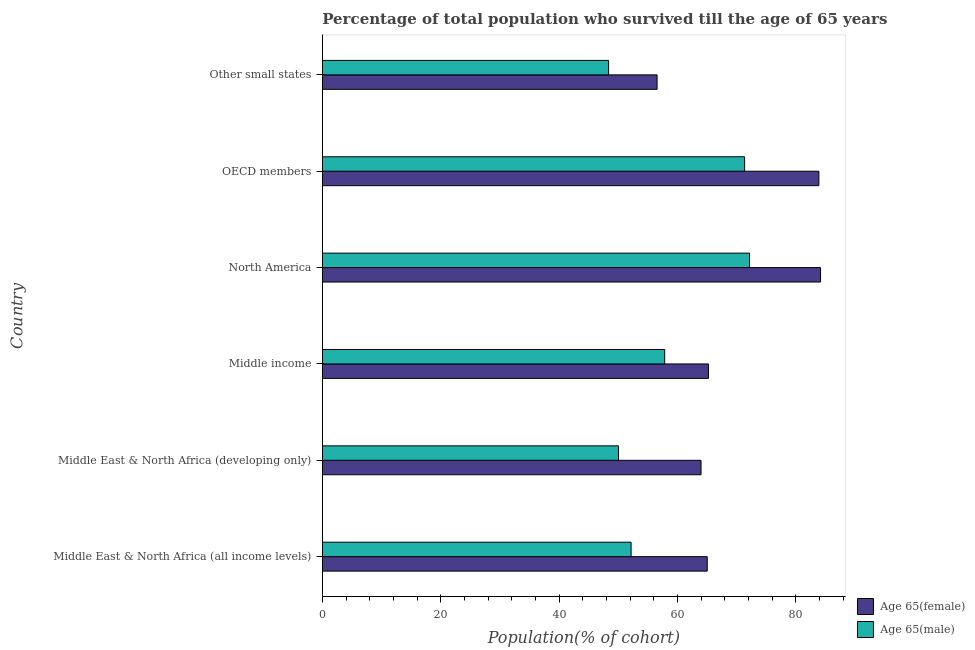How many different coloured bars are there?
Provide a succinct answer. 2. How many groups of bars are there?
Your answer should be very brief. 6. How many bars are there on the 1st tick from the bottom?
Provide a short and direct response. 2. What is the label of the 1st group of bars from the top?
Your answer should be very brief. Other small states. In how many cases, is the number of bars for a given country not equal to the number of legend labels?
Provide a succinct answer. 0. What is the percentage of female population who survived till age of 65 in Middle East & North Africa (all income levels)?
Ensure brevity in your answer.  65.04. Across all countries, what is the maximum percentage of male population who survived till age of 65?
Offer a very short reply. 72.19. Across all countries, what is the minimum percentage of male population who survived till age of 65?
Offer a terse response. 48.37. In which country was the percentage of male population who survived till age of 65 maximum?
Offer a terse response. North America. In which country was the percentage of female population who survived till age of 65 minimum?
Give a very brief answer. Other small states. What is the total percentage of male population who survived till age of 65 in the graph?
Ensure brevity in your answer.  351.99. What is the difference between the percentage of female population who survived till age of 65 in OECD members and that in Other small states?
Your response must be concise. 27.34. What is the difference between the percentage of female population who survived till age of 65 in Middle income and the percentage of male population who survived till age of 65 in Middle East & North Africa (developing only)?
Your response must be concise. 15.2. What is the average percentage of male population who survived till age of 65 per country?
Give a very brief answer. 58.67. What is the difference between the percentage of male population who survived till age of 65 and percentage of female population who survived till age of 65 in North America?
Offer a terse response. -12. What is the ratio of the percentage of male population who survived till age of 65 in OECD members to that in Other small states?
Provide a succinct answer. 1.48. Is the percentage of male population who survived till age of 65 in North America less than that in OECD members?
Keep it short and to the point. No. What is the difference between the highest and the second highest percentage of male population who survived till age of 65?
Offer a very short reply. 0.83. What is the difference between the highest and the lowest percentage of female population who survived till age of 65?
Your answer should be very brief. 27.62. Is the sum of the percentage of female population who survived till age of 65 in Middle East & North Africa (developing only) and Middle income greater than the maximum percentage of male population who survived till age of 65 across all countries?
Your answer should be very brief. Yes. What does the 1st bar from the top in Other small states represents?
Provide a succinct answer. Age 65(male). What does the 2nd bar from the bottom in OECD members represents?
Provide a succinct answer. Age 65(male). How many countries are there in the graph?
Offer a terse response. 6. Does the graph contain any zero values?
Ensure brevity in your answer.  No. Does the graph contain grids?
Provide a short and direct response. No. Where does the legend appear in the graph?
Give a very brief answer. Bottom right. What is the title of the graph?
Offer a terse response. Percentage of total population who survived till the age of 65 years. What is the label or title of the X-axis?
Your answer should be very brief. Population(% of cohort). What is the Population(% of cohort) of Age 65(female) in Middle East & North Africa (all income levels)?
Your answer should be very brief. 65.04. What is the Population(% of cohort) of Age 65(male) in Middle East & North Africa (all income levels)?
Keep it short and to the point. 52.18. What is the Population(% of cohort) in Age 65(female) in Middle East & North Africa (developing only)?
Provide a short and direct response. 63.99. What is the Population(% of cohort) of Age 65(male) in Middle East & North Africa (developing only)?
Your answer should be compact. 50.05. What is the Population(% of cohort) in Age 65(female) in Middle income?
Your answer should be compact. 65.25. What is the Population(% of cohort) of Age 65(male) in Middle income?
Your response must be concise. 57.85. What is the Population(% of cohort) of Age 65(female) in North America?
Offer a very short reply. 84.19. What is the Population(% of cohort) in Age 65(male) in North America?
Your response must be concise. 72.19. What is the Population(% of cohort) of Age 65(female) in OECD members?
Provide a succinct answer. 83.91. What is the Population(% of cohort) of Age 65(male) in OECD members?
Offer a very short reply. 71.36. What is the Population(% of cohort) of Age 65(female) in Other small states?
Keep it short and to the point. 56.57. What is the Population(% of cohort) in Age 65(male) in Other small states?
Ensure brevity in your answer.  48.37. Across all countries, what is the maximum Population(% of cohort) in Age 65(female)?
Provide a succinct answer. 84.19. Across all countries, what is the maximum Population(% of cohort) in Age 65(male)?
Offer a very short reply. 72.19. Across all countries, what is the minimum Population(% of cohort) of Age 65(female)?
Offer a terse response. 56.57. Across all countries, what is the minimum Population(% of cohort) in Age 65(male)?
Ensure brevity in your answer.  48.37. What is the total Population(% of cohort) in Age 65(female) in the graph?
Provide a succinct answer. 418.96. What is the total Population(% of cohort) of Age 65(male) in the graph?
Your response must be concise. 351.99. What is the difference between the Population(% of cohort) of Age 65(female) in Middle East & North Africa (all income levels) and that in Middle East & North Africa (developing only)?
Offer a very short reply. 1.05. What is the difference between the Population(% of cohort) of Age 65(male) in Middle East & North Africa (all income levels) and that in Middle East & North Africa (developing only)?
Your answer should be compact. 2.13. What is the difference between the Population(% of cohort) in Age 65(female) in Middle East & North Africa (all income levels) and that in Middle income?
Offer a terse response. -0.21. What is the difference between the Population(% of cohort) in Age 65(male) in Middle East & North Africa (all income levels) and that in Middle income?
Provide a short and direct response. -5.67. What is the difference between the Population(% of cohort) of Age 65(female) in Middle East & North Africa (all income levels) and that in North America?
Your response must be concise. -19.15. What is the difference between the Population(% of cohort) of Age 65(male) in Middle East & North Africa (all income levels) and that in North America?
Offer a very short reply. -20.01. What is the difference between the Population(% of cohort) in Age 65(female) in Middle East & North Africa (all income levels) and that in OECD members?
Keep it short and to the point. -18.86. What is the difference between the Population(% of cohort) in Age 65(male) in Middle East & North Africa (all income levels) and that in OECD members?
Your answer should be very brief. -19.18. What is the difference between the Population(% of cohort) of Age 65(female) in Middle East & North Africa (all income levels) and that in Other small states?
Your answer should be compact. 8.48. What is the difference between the Population(% of cohort) of Age 65(male) in Middle East & North Africa (all income levels) and that in Other small states?
Give a very brief answer. 3.8. What is the difference between the Population(% of cohort) of Age 65(female) in Middle East & North Africa (developing only) and that in Middle income?
Offer a terse response. -1.26. What is the difference between the Population(% of cohort) of Age 65(male) in Middle East & North Africa (developing only) and that in Middle income?
Provide a short and direct response. -7.8. What is the difference between the Population(% of cohort) of Age 65(female) in Middle East & North Africa (developing only) and that in North America?
Your response must be concise. -20.2. What is the difference between the Population(% of cohort) in Age 65(male) in Middle East & North Africa (developing only) and that in North America?
Offer a very short reply. -22.14. What is the difference between the Population(% of cohort) in Age 65(female) in Middle East & North Africa (developing only) and that in OECD members?
Give a very brief answer. -19.91. What is the difference between the Population(% of cohort) of Age 65(male) in Middle East & North Africa (developing only) and that in OECD members?
Provide a short and direct response. -21.31. What is the difference between the Population(% of cohort) of Age 65(female) in Middle East & North Africa (developing only) and that in Other small states?
Your response must be concise. 7.43. What is the difference between the Population(% of cohort) of Age 65(male) in Middle East & North Africa (developing only) and that in Other small states?
Offer a terse response. 1.68. What is the difference between the Population(% of cohort) of Age 65(female) in Middle income and that in North America?
Your response must be concise. -18.94. What is the difference between the Population(% of cohort) of Age 65(male) in Middle income and that in North America?
Give a very brief answer. -14.34. What is the difference between the Population(% of cohort) in Age 65(female) in Middle income and that in OECD members?
Your response must be concise. -18.66. What is the difference between the Population(% of cohort) in Age 65(male) in Middle income and that in OECD members?
Give a very brief answer. -13.51. What is the difference between the Population(% of cohort) of Age 65(female) in Middle income and that in Other small states?
Offer a very short reply. 8.68. What is the difference between the Population(% of cohort) in Age 65(male) in Middle income and that in Other small states?
Offer a very short reply. 9.48. What is the difference between the Population(% of cohort) of Age 65(female) in North America and that in OECD members?
Provide a short and direct response. 0.28. What is the difference between the Population(% of cohort) of Age 65(male) in North America and that in OECD members?
Keep it short and to the point. 0.83. What is the difference between the Population(% of cohort) in Age 65(female) in North America and that in Other small states?
Give a very brief answer. 27.62. What is the difference between the Population(% of cohort) of Age 65(male) in North America and that in Other small states?
Ensure brevity in your answer.  23.81. What is the difference between the Population(% of cohort) in Age 65(female) in OECD members and that in Other small states?
Provide a succinct answer. 27.34. What is the difference between the Population(% of cohort) in Age 65(male) in OECD members and that in Other small states?
Make the answer very short. 22.98. What is the difference between the Population(% of cohort) in Age 65(female) in Middle East & North Africa (all income levels) and the Population(% of cohort) in Age 65(male) in Middle East & North Africa (developing only)?
Provide a short and direct response. 15. What is the difference between the Population(% of cohort) of Age 65(female) in Middle East & North Africa (all income levels) and the Population(% of cohort) of Age 65(male) in Middle income?
Your response must be concise. 7.19. What is the difference between the Population(% of cohort) in Age 65(female) in Middle East & North Africa (all income levels) and the Population(% of cohort) in Age 65(male) in North America?
Make the answer very short. -7.14. What is the difference between the Population(% of cohort) in Age 65(female) in Middle East & North Africa (all income levels) and the Population(% of cohort) in Age 65(male) in OECD members?
Keep it short and to the point. -6.31. What is the difference between the Population(% of cohort) of Age 65(female) in Middle East & North Africa (all income levels) and the Population(% of cohort) of Age 65(male) in Other small states?
Provide a succinct answer. 16.67. What is the difference between the Population(% of cohort) in Age 65(female) in Middle East & North Africa (developing only) and the Population(% of cohort) in Age 65(male) in Middle income?
Your answer should be compact. 6.14. What is the difference between the Population(% of cohort) in Age 65(female) in Middle East & North Africa (developing only) and the Population(% of cohort) in Age 65(male) in North America?
Make the answer very short. -8.19. What is the difference between the Population(% of cohort) of Age 65(female) in Middle East & North Africa (developing only) and the Population(% of cohort) of Age 65(male) in OECD members?
Your response must be concise. -7.36. What is the difference between the Population(% of cohort) in Age 65(female) in Middle East & North Africa (developing only) and the Population(% of cohort) in Age 65(male) in Other small states?
Give a very brief answer. 15.62. What is the difference between the Population(% of cohort) of Age 65(female) in Middle income and the Population(% of cohort) of Age 65(male) in North America?
Keep it short and to the point. -6.93. What is the difference between the Population(% of cohort) of Age 65(female) in Middle income and the Population(% of cohort) of Age 65(male) in OECD members?
Keep it short and to the point. -6.1. What is the difference between the Population(% of cohort) in Age 65(female) in Middle income and the Population(% of cohort) in Age 65(male) in Other small states?
Your answer should be compact. 16.88. What is the difference between the Population(% of cohort) in Age 65(female) in North America and the Population(% of cohort) in Age 65(male) in OECD members?
Give a very brief answer. 12.83. What is the difference between the Population(% of cohort) of Age 65(female) in North America and the Population(% of cohort) of Age 65(male) in Other small states?
Your answer should be very brief. 35.82. What is the difference between the Population(% of cohort) of Age 65(female) in OECD members and the Population(% of cohort) of Age 65(male) in Other small states?
Ensure brevity in your answer.  35.54. What is the average Population(% of cohort) in Age 65(female) per country?
Provide a succinct answer. 69.83. What is the average Population(% of cohort) of Age 65(male) per country?
Offer a very short reply. 58.67. What is the difference between the Population(% of cohort) in Age 65(female) and Population(% of cohort) in Age 65(male) in Middle East & North Africa (all income levels)?
Provide a succinct answer. 12.87. What is the difference between the Population(% of cohort) in Age 65(female) and Population(% of cohort) in Age 65(male) in Middle East & North Africa (developing only)?
Offer a terse response. 13.95. What is the difference between the Population(% of cohort) of Age 65(female) and Population(% of cohort) of Age 65(male) in Middle income?
Offer a terse response. 7.4. What is the difference between the Population(% of cohort) in Age 65(female) and Population(% of cohort) in Age 65(male) in North America?
Offer a terse response. 12. What is the difference between the Population(% of cohort) in Age 65(female) and Population(% of cohort) in Age 65(male) in OECD members?
Ensure brevity in your answer.  12.55. What is the difference between the Population(% of cohort) in Age 65(female) and Population(% of cohort) in Age 65(male) in Other small states?
Provide a short and direct response. 8.2. What is the ratio of the Population(% of cohort) in Age 65(female) in Middle East & North Africa (all income levels) to that in Middle East & North Africa (developing only)?
Give a very brief answer. 1.02. What is the ratio of the Population(% of cohort) in Age 65(male) in Middle East & North Africa (all income levels) to that in Middle East & North Africa (developing only)?
Ensure brevity in your answer.  1.04. What is the ratio of the Population(% of cohort) in Age 65(male) in Middle East & North Africa (all income levels) to that in Middle income?
Keep it short and to the point. 0.9. What is the ratio of the Population(% of cohort) of Age 65(female) in Middle East & North Africa (all income levels) to that in North America?
Make the answer very short. 0.77. What is the ratio of the Population(% of cohort) in Age 65(male) in Middle East & North Africa (all income levels) to that in North America?
Make the answer very short. 0.72. What is the ratio of the Population(% of cohort) in Age 65(female) in Middle East & North Africa (all income levels) to that in OECD members?
Ensure brevity in your answer.  0.78. What is the ratio of the Population(% of cohort) of Age 65(male) in Middle East & North Africa (all income levels) to that in OECD members?
Your answer should be very brief. 0.73. What is the ratio of the Population(% of cohort) in Age 65(female) in Middle East & North Africa (all income levels) to that in Other small states?
Keep it short and to the point. 1.15. What is the ratio of the Population(% of cohort) of Age 65(male) in Middle East & North Africa (all income levels) to that in Other small states?
Provide a short and direct response. 1.08. What is the ratio of the Population(% of cohort) of Age 65(female) in Middle East & North Africa (developing only) to that in Middle income?
Provide a short and direct response. 0.98. What is the ratio of the Population(% of cohort) of Age 65(male) in Middle East & North Africa (developing only) to that in Middle income?
Ensure brevity in your answer.  0.87. What is the ratio of the Population(% of cohort) of Age 65(female) in Middle East & North Africa (developing only) to that in North America?
Your answer should be very brief. 0.76. What is the ratio of the Population(% of cohort) in Age 65(male) in Middle East & North Africa (developing only) to that in North America?
Ensure brevity in your answer.  0.69. What is the ratio of the Population(% of cohort) of Age 65(female) in Middle East & North Africa (developing only) to that in OECD members?
Your answer should be compact. 0.76. What is the ratio of the Population(% of cohort) of Age 65(male) in Middle East & North Africa (developing only) to that in OECD members?
Offer a terse response. 0.7. What is the ratio of the Population(% of cohort) of Age 65(female) in Middle East & North Africa (developing only) to that in Other small states?
Ensure brevity in your answer.  1.13. What is the ratio of the Population(% of cohort) in Age 65(male) in Middle East & North Africa (developing only) to that in Other small states?
Your answer should be compact. 1.03. What is the ratio of the Population(% of cohort) in Age 65(female) in Middle income to that in North America?
Keep it short and to the point. 0.78. What is the ratio of the Population(% of cohort) of Age 65(male) in Middle income to that in North America?
Ensure brevity in your answer.  0.8. What is the ratio of the Population(% of cohort) in Age 65(female) in Middle income to that in OECD members?
Give a very brief answer. 0.78. What is the ratio of the Population(% of cohort) in Age 65(male) in Middle income to that in OECD members?
Keep it short and to the point. 0.81. What is the ratio of the Population(% of cohort) in Age 65(female) in Middle income to that in Other small states?
Keep it short and to the point. 1.15. What is the ratio of the Population(% of cohort) of Age 65(male) in Middle income to that in Other small states?
Give a very brief answer. 1.2. What is the ratio of the Population(% of cohort) in Age 65(male) in North America to that in OECD members?
Your answer should be compact. 1.01. What is the ratio of the Population(% of cohort) of Age 65(female) in North America to that in Other small states?
Your response must be concise. 1.49. What is the ratio of the Population(% of cohort) in Age 65(male) in North America to that in Other small states?
Keep it short and to the point. 1.49. What is the ratio of the Population(% of cohort) in Age 65(female) in OECD members to that in Other small states?
Your answer should be compact. 1.48. What is the ratio of the Population(% of cohort) of Age 65(male) in OECD members to that in Other small states?
Your response must be concise. 1.48. What is the difference between the highest and the second highest Population(% of cohort) in Age 65(female)?
Make the answer very short. 0.28. What is the difference between the highest and the second highest Population(% of cohort) of Age 65(male)?
Your answer should be compact. 0.83. What is the difference between the highest and the lowest Population(% of cohort) in Age 65(female)?
Ensure brevity in your answer.  27.62. What is the difference between the highest and the lowest Population(% of cohort) of Age 65(male)?
Keep it short and to the point. 23.81. 